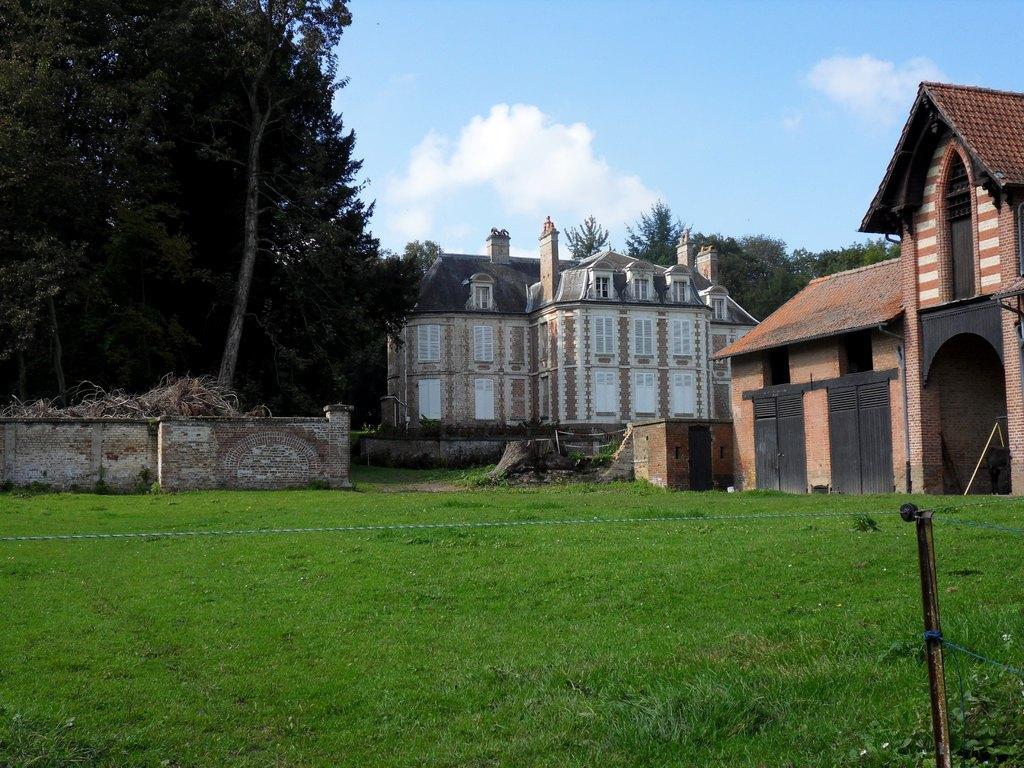Can you describe this image briefly? In this image we can see buildings, trees, grass, wall, sky and clouds. 